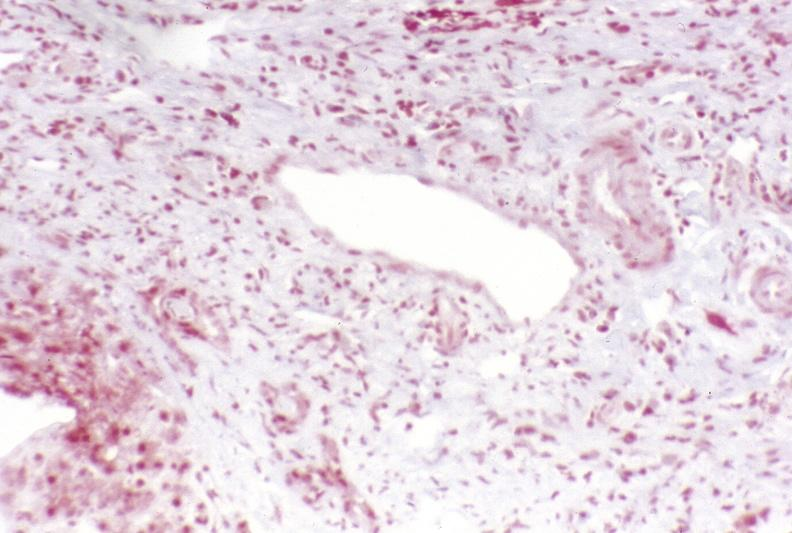what is present?
Answer the question using a single word or phrase. Liver 